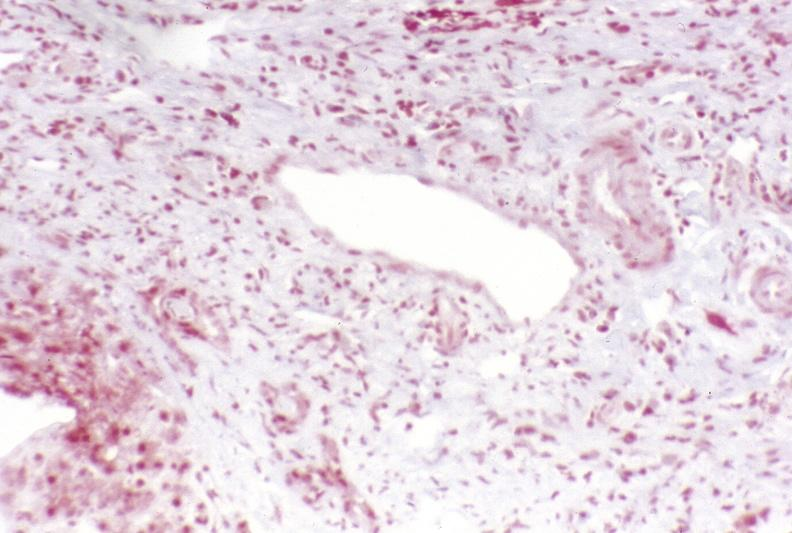what is present?
Answer the question using a single word or phrase. Liver 